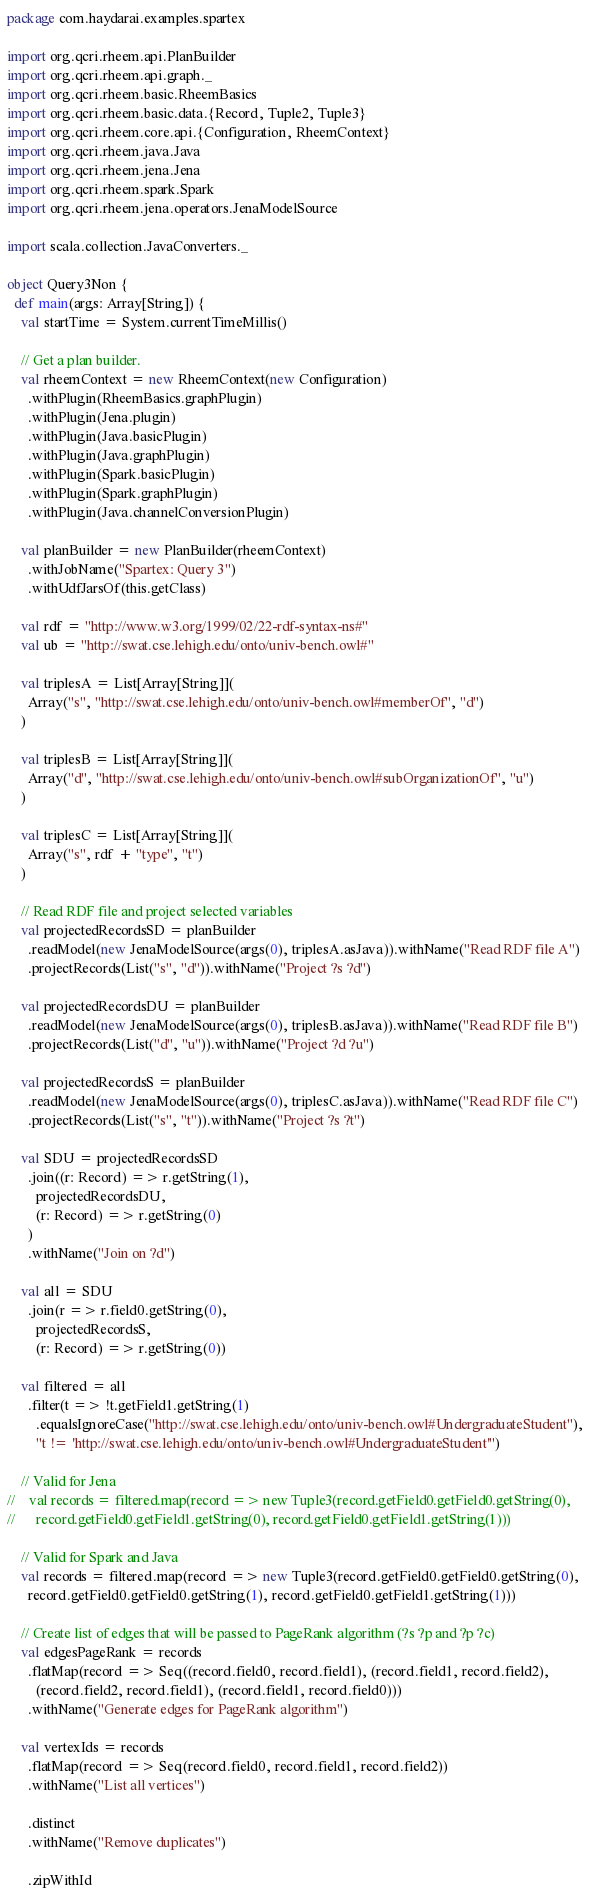<code> <loc_0><loc_0><loc_500><loc_500><_Scala_>package com.haydarai.examples.spartex

import org.qcri.rheem.api.PlanBuilder
import org.qcri.rheem.api.graph._
import org.qcri.rheem.basic.RheemBasics
import org.qcri.rheem.basic.data.{Record, Tuple2, Tuple3}
import org.qcri.rheem.core.api.{Configuration, RheemContext}
import org.qcri.rheem.java.Java
import org.qcri.rheem.jena.Jena
import org.qcri.rheem.spark.Spark
import org.qcri.rheem.jena.operators.JenaModelSource

import scala.collection.JavaConverters._

object Query3Non {
  def main(args: Array[String]) {
    val startTime = System.currentTimeMillis()

    // Get a plan builder.
    val rheemContext = new RheemContext(new Configuration)
      .withPlugin(RheemBasics.graphPlugin)
      .withPlugin(Jena.plugin)
      .withPlugin(Java.basicPlugin)
      .withPlugin(Java.graphPlugin)
      .withPlugin(Spark.basicPlugin)
      .withPlugin(Spark.graphPlugin)
      .withPlugin(Java.channelConversionPlugin)

    val planBuilder = new PlanBuilder(rheemContext)
      .withJobName("Spartex: Query 3")
      .withUdfJarsOf(this.getClass)

    val rdf = "http://www.w3.org/1999/02/22-rdf-syntax-ns#"
    val ub = "http://swat.cse.lehigh.edu/onto/univ-bench.owl#"

    val triplesA = List[Array[String]](
      Array("s", "http://swat.cse.lehigh.edu/onto/univ-bench.owl#memberOf", "d")
    )

    val triplesB = List[Array[String]](
      Array("d", "http://swat.cse.lehigh.edu/onto/univ-bench.owl#subOrganizationOf", "u")
    )

    val triplesC = List[Array[String]](
      Array("s", rdf + "type", "t")
    )

    // Read RDF file and project selected variables
    val projectedRecordsSD = planBuilder
      .readModel(new JenaModelSource(args(0), triplesA.asJava)).withName("Read RDF file A")
      .projectRecords(List("s", "d")).withName("Project ?s ?d")

    val projectedRecordsDU = planBuilder
      .readModel(new JenaModelSource(args(0), triplesB.asJava)).withName("Read RDF file B")
      .projectRecords(List("d", "u")).withName("Project ?d ?u")

    val projectedRecordsS = planBuilder
      .readModel(new JenaModelSource(args(0), triplesC.asJava)).withName("Read RDF file C")
      .projectRecords(List("s", "t")).withName("Project ?s ?t")

    val SDU = projectedRecordsSD
      .join((r: Record) => r.getString(1),
        projectedRecordsDU,
        (r: Record) => r.getString(0)
      )
      .withName("Join on ?d")

    val all = SDU
      .join(r => r.field0.getString(0),
        projectedRecordsS,
        (r: Record) => r.getString(0))

    val filtered = all
      .filter(t => !t.getField1.getString(1)
        .equalsIgnoreCase("http://swat.cse.lehigh.edu/onto/univ-bench.owl#UndergraduateStudent"),
        "t != 'http://swat.cse.lehigh.edu/onto/univ-bench.owl#UndergraduateStudent'")

    // Valid for Jena
//    val records = filtered.map(record => new Tuple3(record.getField0.getField0.getString(0),
//      record.getField0.getField1.getString(0), record.getField0.getField1.getString(1)))

    // Valid for Spark and Java
    val records = filtered.map(record => new Tuple3(record.getField0.getField0.getString(0),
      record.getField0.getField0.getString(1), record.getField0.getField1.getString(1)))

    // Create list of edges that will be passed to PageRank algorithm (?s ?p and ?p ?c)
    val edgesPageRank = records
      .flatMap(record => Seq((record.field0, record.field1), (record.field1, record.field2),
        (record.field2, record.field1), (record.field1, record.field0)))
      .withName("Generate edges for PageRank algorithm")

    val vertexIds = records
      .flatMap(record => Seq(record.field0, record.field1, record.field2))
      .withName("List all vertices")

      .distinct
      .withName("Remove duplicates")

      .zipWithId</code> 